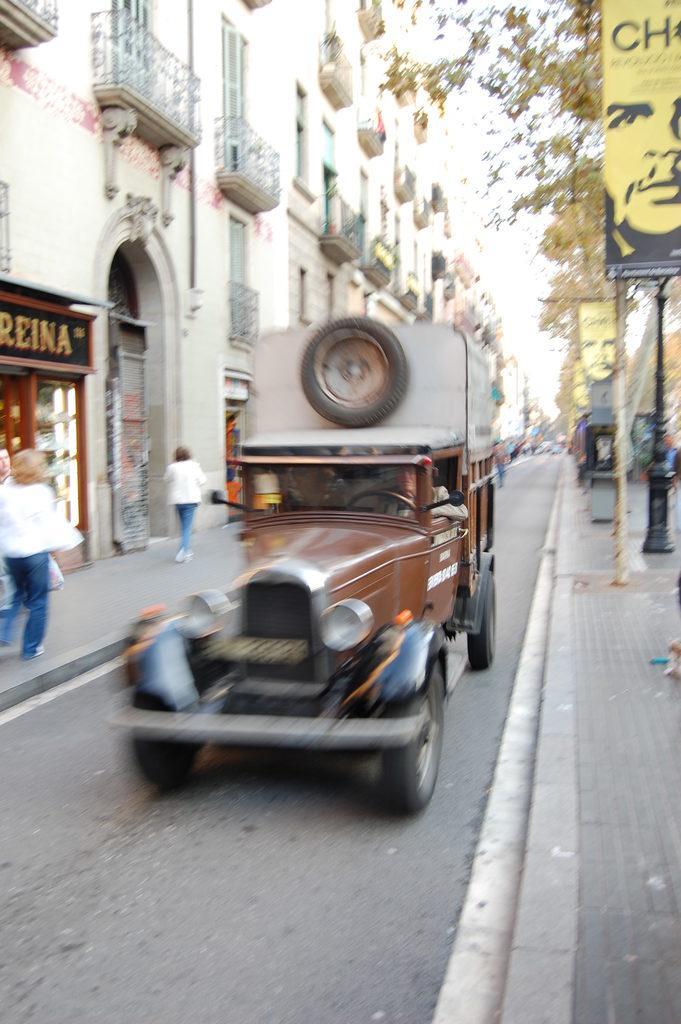Could you give a brief overview of what you see in this image? In this image we can see a person driving a vehicle on the road, there are some buildings, windows, grille, trees and people, also we can see a board with some text and image, in the background we can see the sky. 